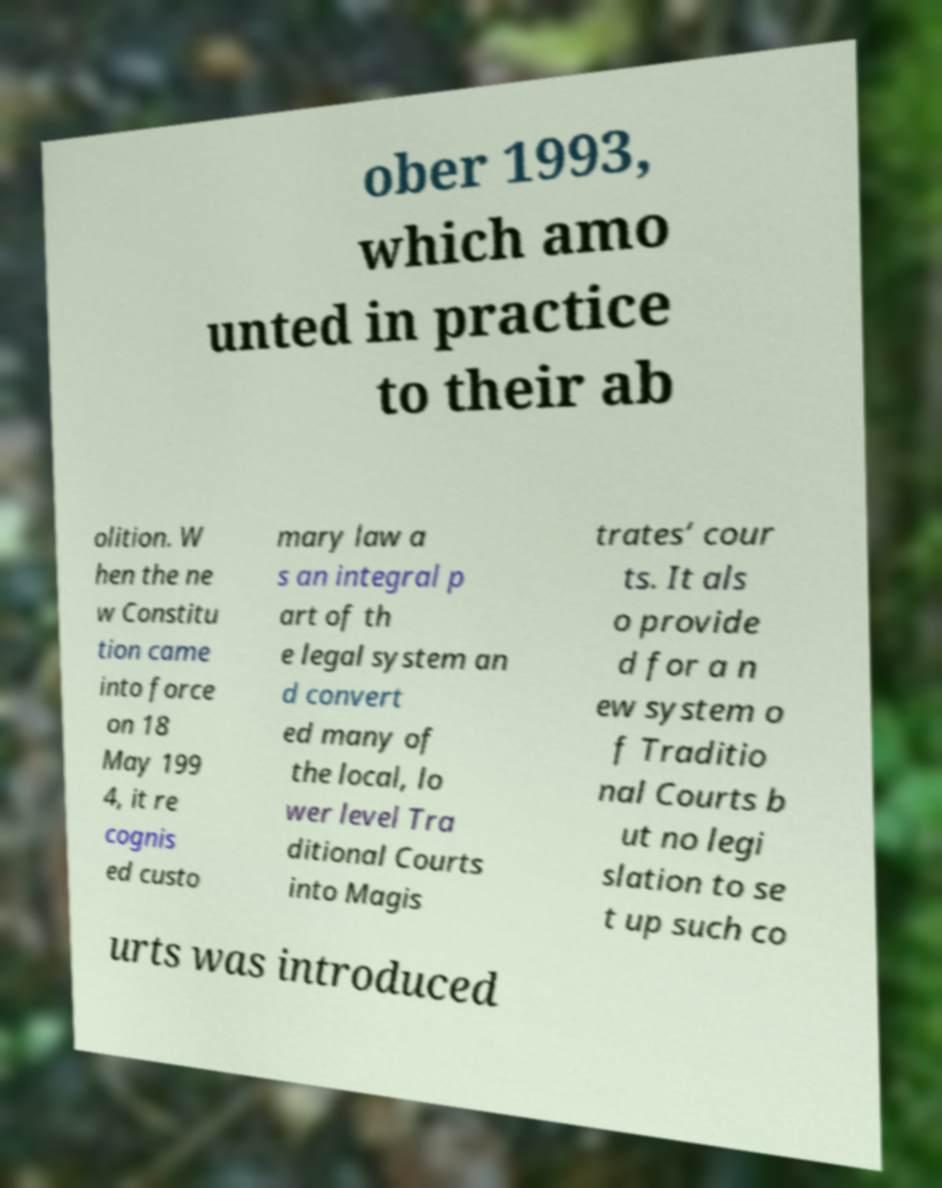I need the written content from this picture converted into text. Can you do that? ober 1993, which amo unted in practice to their ab olition. W hen the ne w Constitu tion came into force on 18 May 199 4, it re cognis ed custo mary law a s an integral p art of th e legal system an d convert ed many of the local, lo wer level Tra ditional Courts into Magis trates’ cour ts. It als o provide d for a n ew system o f Traditio nal Courts b ut no legi slation to se t up such co urts was introduced 